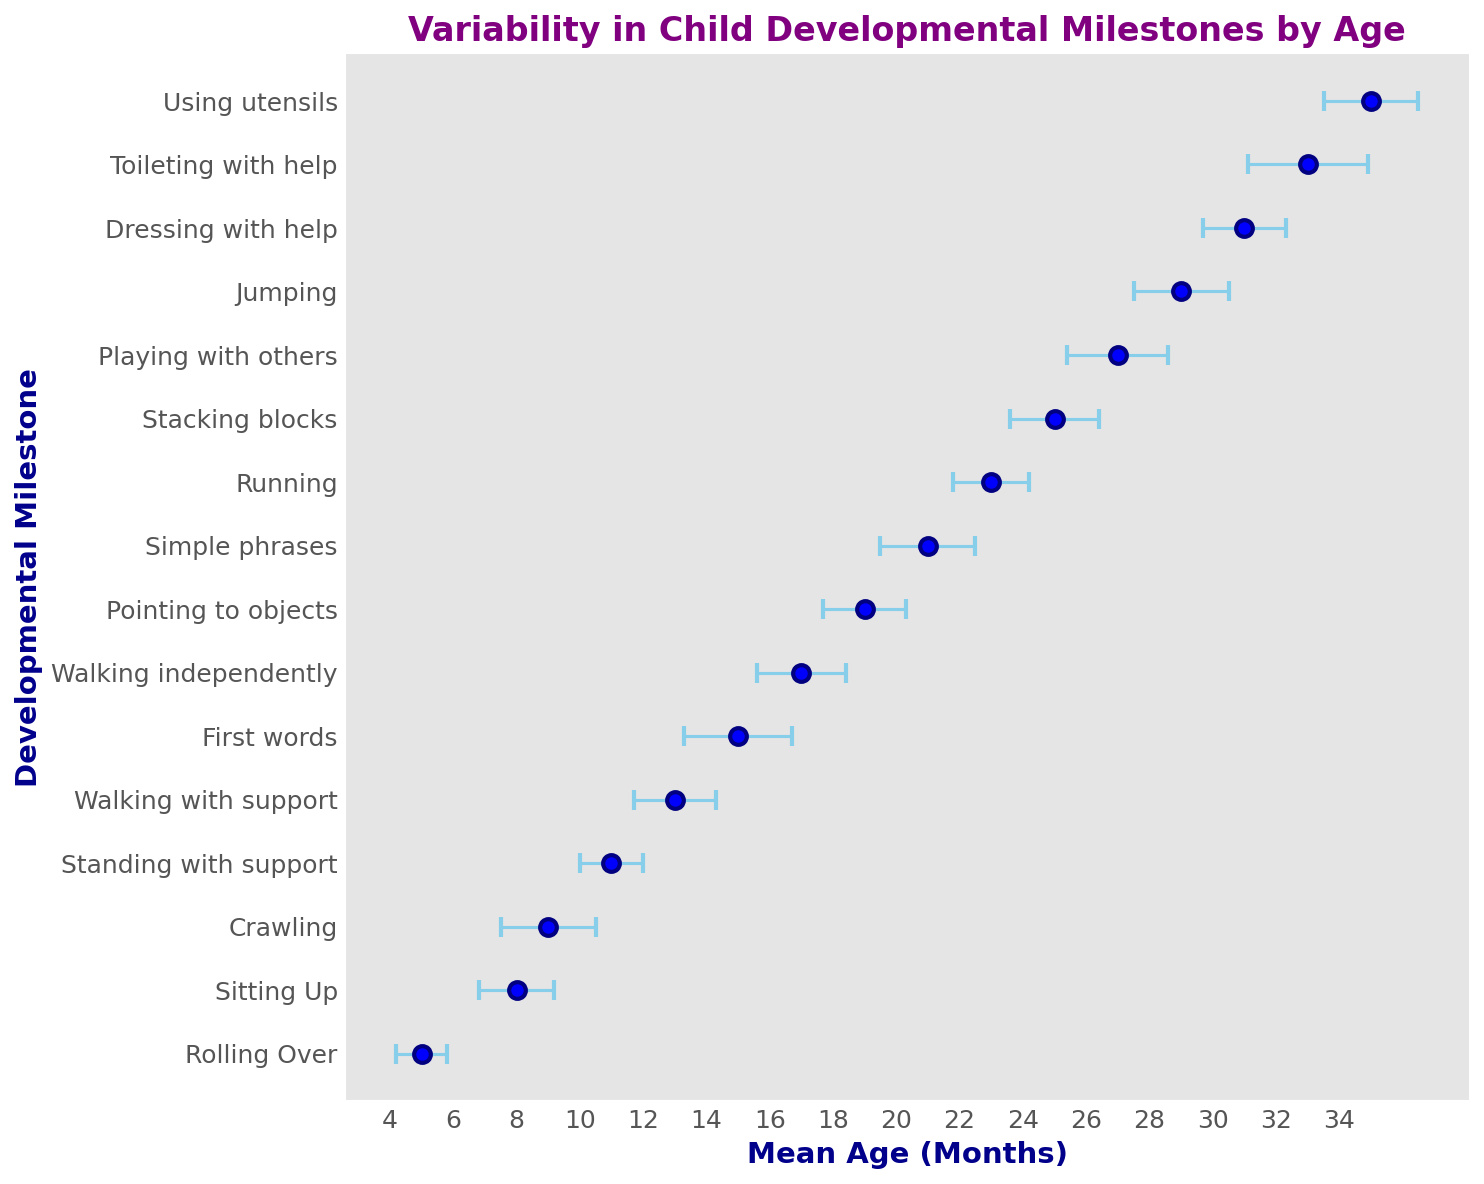what's the average standard deviation for all milestones? To find the average standard deviation, sum all the standard deviations and divide by the number of milestones. (0.8 + 1.2 + 1.5 + 1.0 + 1.3 + 1.7 + 1.4 + 1.3 + 1.5 + 1.2 + 1.4 + 1.6 + 1.5 + 1.3 + 1.9 + 1.5) / 16 = 22.1 / 16 = 1.38125
Answer: 1.38 Which milestone has the highest standard deviation? Look at the error bars' lengths on the chart. The largest error bar corresponds to "Toileting with help" with a standard deviation of 1.9 months.
Answer: Toileting with help Are there any milestones with the same mean age? Scan mean ages on the x-axis. Each milestone has a unique mean age in the given data.
Answer: No Which milestone occurs at the earliest mean age? Identify the milestone with the lowest mean age. "Rolling Over" has the earliest mean age of 5 months.
Answer: Rolling Over How does the variability in "Walking with support" compare to "Sitting Up"? Compare the lengths of the error bars for "Walking with support" and "Sitting Up". "Walking with support" has a standard deviation of 1.3, whereas "Sitting Up" has a standard deviation of 1.2. Thus, "Walking with support" has slightly more variability.
Answer: Walking with support has slightly more variability What is the range of mean ages for the developmental milestones shown? The range is calculated by subtracting the smallest mean age from the largest mean age. The smallest mean age is 5 months (Rolling Over) and the largest is 35 months (Using utensils). 35 - 5 = 30
Answer: 30 How do the standard deviations for "Running" and "Jumping" compare? Look at the error bars for "Running" and "Jumping". Both have a standard deviation of 1.5 months, so they are equal.
Answer: Equal What is the mean age difference between "First words" and "Simple phrases"? Subtract the mean age of "First words" from the mean age of "Simple phrases". 21 - 15 = 6
Answer: 6 Which developmental milestone has the shortest error bar? Identify the shortest error bar visually. "Rolling Over" has the shortest error bar, indicating a standard deviation of 0.8.
Answer: Rolling Over 